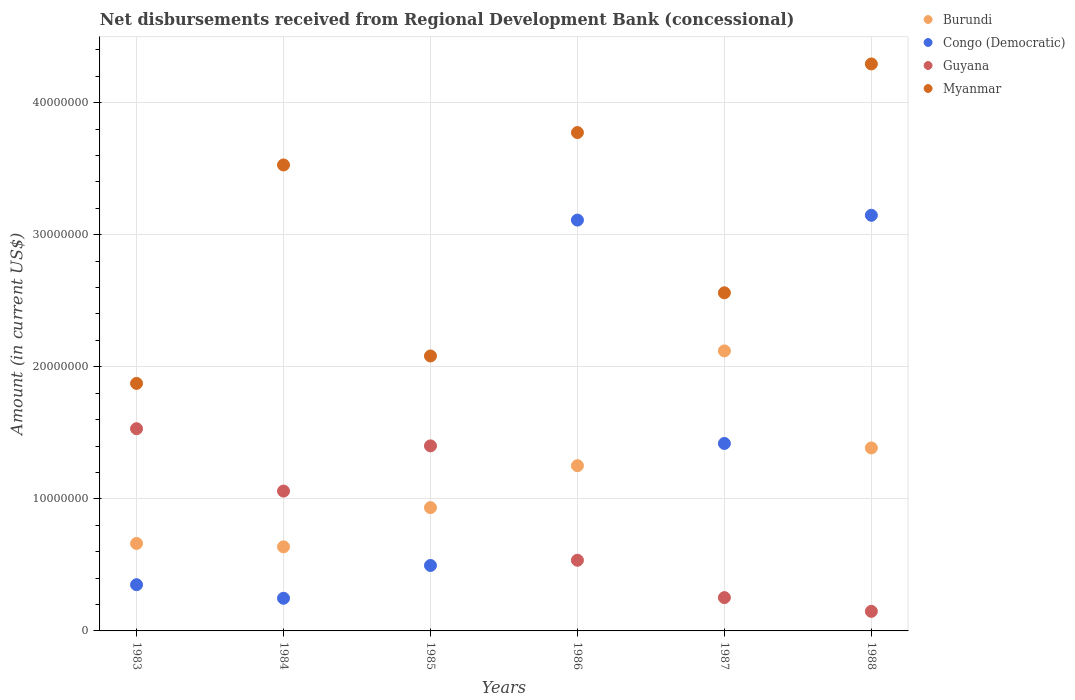How many different coloured dotlines are there?
Your response must be concise. 4. Is the number of dotlines equal to the number of legend labels?
Your response must be concise. Yes. What is the amount of disbursements received from Regional Development Bank in Guyana in 1984?
Your answer should be compact. 1.06e+07. Across all years, what is the maximum amount of disbursements received from Regional Development Bank in Myanmar?
Your answer should be very brief. 4.29e+07. Across all years, what is the minimum amount of disbursements received from Regional Development Bank in Congo (Democratic)?
Ensure brevity in your answer.  2.47e+06. In which year was the amount of disbursements received from Regional Development Bank in Burundi maximum?
Make the answer very short. 1987. In which year was the amount of disbursements received from Regional Development Bank in Burundi minimum?
Make the answer very short. 1984. What is the total amount of disbursements received from Regional Development Bank in Myanmar in the graph?
Your response must be concise. 1.81e+08. What is the difference between the amount of disbursements received from Regional Development Bank in Myanmar in 1983 and that in 1984?
Your answer should be compact. -1.65e+07. What is the difference between the amount of disbursements received from Regional Development Bank in Myanmar in 1983 and the amount of disbursements received from Regional Development Bank in Guyana in 1986?
Provide a short and direct response. 1.34e+07. What is the average amount of disbursements received from Regional Development Bank in Myanmar per year?
Your response must be concise. 3.02e+07. In the year 1987, what is the difference between the amount of disbursements received from Regional Development Bank in Guyana and amount of disbursements received from Regional Development Bank in Congo (Democratic)?
Offer a terse response. -1.17e+07. What is the ratio of the amount of disbursements received from Regional Development Bank in Congo (Democratic) in 1987 to that in 1988?
Your response must be concise. 0.45. Is the amount of disbursements received from Regional Development Bank in Burundi in 1986 less than that in 1987?
Your response must be concise. Yes. What is the difference between the highest and the second highest amount of disbursements received from Regional Development Bank in Guyana?
Offer a very short reply. 1.30e+06. What is the difference between the highest and the lowest amount of disbursements received from Regional Development Bank in Myanmar?
Make the answer very short. 2.42e+07. Is it the case that in every year, the sum of the amount of disbursements received from Regional Development Bank in Congo (Democratic) and amount of disbursements received from Regional Development Bank in Burundi  is greater than the amount of disbursements received from Regional Development Bank in Myanmar?
Your answer should be very brief. No. Does the amount of disbursements received from Regional Development Bank in Myanmar monotonically increase over the years?
Keep it short and to the point. No. Is the amount of disbursements received from Regional Development Bank in Burundi strictly less than the amount of disbursements received from Regional Development Bank in Myanmar over the years?
Your answer should be very brief. Yes. How many years are there in the graph?
Offer a very short reply. 6. Are the values on the major ticks of Y-axis written in scientific E-notation?
Your response must be concise. No. Does the graph contain any zero values?
Offer a very short reply. No. Where does the legend appear in the graph?
Your answer should be very brief. Top right. How many legend labels are there?
Your response must be concise. 4. What is the title of the graph?
Offer a terse response. Net disbursements received from Regional Development Bank (concessional). What is the label or title of the X-axis?
Offer a terse response. Years. What is the Amount (in current US$) in Burundi in 1983?
Offer a very short reply. 6.62e+06. What is the Amount (in current US$) in Congo (Democratic) in 1983?
Keep it short and to the point. 3.50e+06. What is the Amount (in current US$) of Guyana in 1983?
Give a very brief answer. 1.53e+07. What is the Amount (in current US$) in Myanmar in 1983?
Provide a short and direct response. 1.87e+07. What is the Amount (in current US$) of Burundi in 1984?
Your response must be concise. 6.37e+06. What is the Amount (in current US$) in Congo (Democratic) in 1984?
Provide a short and direct response. 2.47e+06. What is the Amount (in current US$) of Guyana in 1984?
Your answer should be very brief. 1.06e+07. What is the Amount (in current US$) in Myanmar in 1984?
Your response must be concise. 3.53e+07. What is the Amount (in current US$) of Burundi in 1985?
Keep it short and to the point. 9.34e+06. What is the Amount (in current US$) in Congo (Democratic) in 1985?
Your answer should be very brief. 4.96e+06. What is the Amount (in current US$) of Guyana in 1985?
Provide a succinct answer. 1.40e+07. What is the Amount (in current US$) in Myanmar in 1985?
Your answer should be very brief. 2.08e+07. What is the Amount (in current US$) in Burundi in 1986?
Your answer should be compact. 1.25e+07. What is the Amount (in current US$) of Congo (Democratic) in 1986?
Give a very brief answer. 3.11e+07. What is the Amount (in current US$) in Guyana in 1986?
Give a very brief answer. 5.35e+06. What is the Amount (in current US$) of Myanmar in 1986?
Offer a terse response. 3.77e+07. What is the Amount (in current US$) of Burundi in 1987?
Provide a succinct answer. 2.12e+07. What is the Amount (in current US$) in Congo (Democratic) in 1987?
Make the answer very short. 1.42e+07. What is the Amount (in current US$) in Guyana in 1987?
Your response must be concise. 2.52e+06. What is the Amount (in current US$) of Myanmar in 1987?
Ensure brevity in your answer.  2.56e+07. What is the Amount (in current US$) of Burundi in 1988?
Give a very brief answer. 1.39e+07. What is the Amount (in current US$) of Congo (Democratic) in 1988?
Provide a succinct answer. 3.15e+07. What is the Amount (in current US$) in Guyana in 1988?
Make the answer very short. 1.48e+06. What is the Amount (in current US$) in Myanmar in 1988?
Keep it short and to the point. 4.29e+07. Across all years, what is the maximum Amount (in current US$) in Burundi?
Keep it short and to the point. 2.12e+07. Across all years, what is the maximum Amount (in current US$) in Congo (Democratic)?
Make the answer very short. 3.15e+07. Across all years, what is the maximum Amount (in current US$) of Guyana?
Offer a very short reply. 1.53e+07. Across all years, what is the maximum Amount (in current US$) in Myanmar?
Provide a short and direct response. 4.29e+07. Across all years, what is the minimum Amount (in current US$) of Burundi?
Keep it short and to the point. 6.37e+06. Across all years, what is the minimum Amount (in current US$) in Congo (Democratic)?
Keep it short and to the point. 2.47e+06. Across all years, what is the minimum Amount (in current US$) of Guyana?
Ensure brevity in your answer.  1.48e+06. Across all years, what is the minimum Amount (in current US$) in Myanmar?
Your response must be concise. 1.87e+07. What is the total Amount (in current US$) of Burundi in the graph?
Provide a short and direct response. 6.99e+07. What is the total Amount (in current US$) of Congo (Democratic) in the graph?
Your response must be concise. 8.77e+07. What is the total Amount (in current US$) of Guyana in the graph?
Make the answer very short. 4.93e+07. What is the total Amount (in current US$) of Myanmar in the graph?
Your response must be concise. 1.81e+08. What is the difference between the Amount (in current US$) of Burundi in 1983 and that in 1984?
Give a very brief answer. 2.53e+05. What is the difference between the Amount (in current US$) of Congo (Democratic) in 1983 and that in 1984?
Your response must be concise. 1.03e+06. What is the difference between the Amount (in current US$) of Guyana in 1983 and that in 1984?
Offer a terse response. 4.72e+06. What is the difference between the Amount (in current US$) of Myanmar in 1983 and that in 1984?
Ensure brevity in your answer.  -1.65e+07. What is the difference between the Amount (in current US$) of Burundi in 1983 and that in 1985?
Your answer should be compact. -2.72e+06. What is the difference between the Amount (in current US$) in Congo (Democratic) in 1983 and that in 1985?
Your answer should be very brief. -1.46e+06. What is the difference between the Amount (in current US$) in Guyana in 1983 and that in 1985?
Give a very brief answer. 1.30e+06. What is the difference between the Amount (in current US$) in Myanmar in 1983 and that in 1985?
Keep it short and to the point. -2.08e+06. What is the difference between the Amount (in current US$) in Burundi in 1983 and that in 1986?
Offer a very short reply. -5.89e+06. What is the difference between the Amount (in current US$) in Congo (Democratic) in 1983 and that in 1986?
Your answer should be compact. -2.76e+07. What is the difference between the Amount (in current US$) in Guyana in 1983 and that in 1986?
Your answer should be compact. 9.96e+06. What is the difference between the Amount (in current US$) of Myanmar in 1983 and that in 1986?
Provide a short and direct response. -1.90e+07. What is the difference between the Amount (in current US$) in Burundi in 1983 and that in 1987?
Keep it short and to the point. -1.46e+07. What is the difference between the Amount (in current US$) of Congo (Democratic) in 1983 and that in 1987?
Make the answer very short. -1.07e+07. What is the difference between the Amount (in current US$) in Guyana in 1983 and that in 1987?
Ensure brevity in your answer.  1.28e+07. What is the difference between the Amount (in current US$) in Myanmar in 1983 and that in 1987?
Keep it short and to the point. -6.86e+06. What is the difference between the Amount (in current US$) of Burundi in 1983 and that in 1988?
Ensure brevity in your answer.  -7.23e+06. What is the difference between the Amount (in current US$) in Congo (Democratic) in 1983 and that in 1988?
Keep it short and to the point. -2.80e+07. What is the difference between the Amount (in current US$) of Guyana in 1983 and that in 1988?
Offer a very short reply. 1.38e+07. What is the difference between the Amount (in current US$) in Myanmar in 1983 and that in 1988?
Offer a terse response. -2.42e+07. What is the difference between the Amount (in current US$) of Burundi in 1984 and that in 1985?
Your response must be concise. -2.97e+06. What is the difference between the Amount (in current US$) in Congo (Democratic) in 1984 and that in 1985?
Provide a short and direct response. -2.48e+06. What is the difference between the Amount (in current US$) of Guyana in 1984 and that in 1985?
Provide a short and direct response. -3.42e+06. What is the difference between the Amount (in current US$) in Myanmar in 1984 and that in 1985?
Your answer should be compact. 1.45e+07. What is the difference between the Amount (in current US$) of Burundi in 1984 and that in 1986?
Offer a very short reply. -6.14e+06. What is the difference between the Amount (in current US$) of Congo (Democratic) in 1984 and that in 1986?
Provide a succinct answer. -2.86e+07. What is the difference between the Amount (in current US$) in Guyana in 1984 and that in 1986?
Your answer should be very brief. 5.24e+06. What is the difference between the Amount (in current US$) in Myanmar in 1984 and that in 1986?
Provide a succinct answer. -2.45e+06. What is the difference between the Amount (in current US$) in Burundi in 1984 and that in 1987?
Provide a short and direct response. -1.48e+07. What is the difference between the Amount (in current US$) of Congo (Democratic) in 1984 and that in 1987?
Your answer should be compact. -1.17e+07. What is the difference between the Amount (in current US$) of Guyana in 1984 and that in 1987?
Make the answer very short. 8.07e+06. What is the difference between the Amount (in current US$) of Myanmar in 1984 and that in 1987?
Your answer should be compact. 9.68e+06. What is the difference between the Amount (in current US$) of Burundi in 1984 and that in 1988?
Make the answer very short. -7.49e+06. What is the difference between the Amount (in current US$) in Congo (Democratic) in 1984 and that in 1988?
Your answer should be compact. -2.90e+07. What is the difference between the Amount (in current US$) of Guyana in 1984 and that in 1988?
Your answer should be very brief. 9.11e+06. What is the difference between the Amount (in current US$) of Myanmar in 1984 and that in 1988?
Offer a terse response. -7.65e+06. What is the difference between the Amount (in current US$) in Burundi in 1985 and that in 1986?
Offer a very short reply. -3.18e+06. What is the difference between the Amount (in current US$) in Congo (Democratic) in 1985 and that in 1986?
Give a very brief answer. -2.62e+07. What is the difference between the Amount (in current US$) in Guyana in 1985 and that in 1986?
Keep it short and to the point. 8.66e+06. What is the difference between the Amount (in current US$) in Myanmar in 1985 and that in 1986?
Ensure brevity in your answer.  -1.69e+07. What is the difference between the Amount (in current US$) of Burundi in 1985 and that in 1987?
Make the answer very short. -1.19e+07. What is the difference between the Amount (in current US$) in Congo (Democratic) in 1985 and that in 1987?
Offer a very short reply. -9.24e+06. What is the difference between the Amount (in current US$) in Guyana in 1985 and that in 1987?
Your answer should be compact. 1.15e+07. What is the difference between the Amount (in current US$) of Myanmar in 1985 and that in 1987?
Provide a short and direct response. -4.78e+06. What is the difference between the Amount (in current US$) of Burundi in 1985 and that in 1988?
Your response must be concise. -4.52e+06. What is the difference between the Amount (in current US$) in Congo (Democratic) in 1985 and that in 1988?
Ensure brevity in your answer.  -2.65e+07. What is the difference between the Amount (in current US$) in Guyana in 1985 and that in 1988?
Give a very brief answer. 1.25e+07. What is the difference between the Amount (in current US$) of Myanmar in 1985 and that in 1988?
Your response must be concise. -2.21e+07. What is the difference between the Amount (in current US$) in Burundi in 1986 and that in 1987?
Make the answer very short. -8.69e+06. What is the difference between the Amount (in current US$) of Congo (Democratic) in 1986 and that in 1987?
Offer a terse response. 1.69e+07. What is the difference between the Amount (in current US$) in Guyana in 1986 and that in 1987?
Your response must be concise. 2.83e+06. What is the difference between the Amount (in current US$) in Myanmar in 1986 and that in 1987?
Your answer should be compact. 1.21e+07. What is the difference between the Amount (in current US$) in Burundi in 1986 and that in 1988?
Provide a succinct answer. -1.34e+06. What is the difference between the Amount (in current US$) of Congo (Democratic) in 1986 and that in 1988?
Your answer should be very brief. -3.65e+05. What is the difference between the Amount (in current US$) of Guyana in 1986 and that in 1988?
Your answer should be very brief. 3.87e+06. What is the difference between the Amount (in current US$) of Myanmar in 1986 and that in 1988?
Provide a succinct answer. -5.20e+06. What is the difference between the Amount (in current US$) in Burundi in 1987 and that in 1988?
Give a very brief answer. 7.35e+06. What is the difference between the Amount (in current US$) of Congo (Democratic) in 1987 and that in 1988?
Your response must be concise. -1.73e+07. What is the difference between the Amount (in current US$) in Guyana in 1987 and that in 1988?
Offer a terse response. 1.04e+06. What is the difference between the Amount (in current US$) in Myanmar in 1987 and that in 1988?
Make the answer very short. -1.73e+07. What is the difference between the Amount (in current US$) of Burundi in 1983 and the Amount (in current US$) of Congo (Democratic) in 1984?
Make the answer very short. 4.15e+06. What is the difference between the Amount (in current US$) in Burundi in 1983 and the Amount (in current US$) in Guyana in 1984?
Your answer should be compact. -3.97e+06. What is the difference between the Amount (in current US$) of Burundi in 1983 and the Amount (in current US$) of Myanmar in 1984?
Keep it short and to the point. -2.87e+07. What is the difference between the Amount (in current US$) of Congo (Democratic) in 1983 and the Amount (in current US$) of Guyana in 1984?
Offer a very short reply. -7.09e+06. What is the difference between the Amount (in current US$) of Congo (Democratic) in 1983 and the Amount (in current US$) of Myanmar in 1984?
Provide a short and direct response. -3.18e+07. What is the difference between the Amount (in current US$) of Guyana in 1983 and the Amount (in current US$) of Myanmar in 1984?
Provide a short and direct response. -2.00e+07. What is the difference between the Amount (in current US$) in Burundi in 1983 and the Amount (in current US$) in Congo (Democratic) in 1985?
Ensure brevity in your answer.  1.66e+06. What is the difference between the Amount (in current US$) of Burundi in 1983 and the Amount (in current US$) of Guyana in 1985?
Ensure brevity in your answer.  -7.39e+06. What is the difference between the Amount (in current US$) in Burundi in 1983 and the Amount (in current US$) in Myanmar in 1985?
Your answer should be very brief. -1.42e+07. What is the difference between the Amount (in current US$) in Congo (Democratic) in 1983 and the Amount (in current US$) in Guyana in 1985?
Provide a short and direct response. -1.05e+07. What is the difference between the Amount (in current US$) in Congo (Democratic) in 1983 and the Amount (in current US$) in Myanmar in 1985?
Make the answer very short. -1.73e+07. What is the difference between the Amount (in current US$) of Guyana in 1983 and the Amount (in current US$) of Myanmar in 1985?
Give a very brief answer. -5.51e+06. What is the difference between the Amount (in current US$) of Burundi in 1983 and the Amount (in current US$) of Congo (Democratic) in 1986?
Make the answer very short. -2.45e+07. What is the difference between the Amount (in current US$) in Burundi in 1983 and the Amount (in current US$) in Guyana in 1986?
Provide a succinct answer. 1.27e+06. What is the difference between the Amount (in current US$) in Burundi in 1983 and the Amount (in current US$) in Myanmar in 1986?
Give a very brief answer. -3.11e+07. What is the difference between the Amount (in current US$) of Congo (Democratic) in 1983 and the Amount (in current US$) of Guyana in 1986?
Keep it short and to the point. -1.85e+06. What is the difference between the Amount (in current US$) of Congo (Democratic) in 1983 and the Amount (in current US$) of Myanmar in 1986?
Offer a terse response. -3.42e+07. What is the difference between the Amount (in current US$) of Guyana in 1983 and the Amount (in current US$) of Myanmar in 1986?
Your answer should be compact. -2.24e+07. What is the difference between the Amount (in current US$) in Burundi in 1983 and the Amount (in current US$) in Congo (Democratic) in 1987?
Offer a terse response. -7.57e+06. What is the difference between the Amount (in current US$) in Burundi in 1983 and the Amount (in current US$) in Guyana in 1987?
Offer a very short reply. 4.10e+06. What is the difference between the Amount (in current US$) in Burundi in 1983 and the Amount (in current US$) in Myanmar in 1987?
Offer a very short reply. -1.90e+07. What is the difference between the Amount (in current US$) in Congo (Democratic) in 1983 and the Amount (in current US$) in Guyana in 1987?
Ensure brevity in your answer.  9.77e+05. What is the difference between the Amount (in current US$) of Congo (Democratic) in 1983 and the Amount (in current US$) of Myanmar in 1987?
Give a very brief answer. -2.21e+07. What is the difference between the Amount (in current US$) of Guyana in 1983 and the Amount (in current US$) of Myanmar in 1987?
Ensure brevity in your answer.  -1.03e+07. What is the difference between the Amount (in current US$) of Burundi in 1983 and the Amount (in current US$) of Congo (Democratic) in 1988?
Offer a terse response. -2.49e+07. What is the difference between the Amount (in current US$) in Burundi in 1983 and the Amount (in current US$) in Guyana in 1988?
Your answer should be compact. 5.14e+06. What is the difference between the Amount (in current US$) of Burundi in 1983 and the Amount (in current US$) of Myanmar in 1988?
Provide a short and direct response. -3.63e+07. What is the difference between the Amount (in current US$) in Congo (Democratic) in 1983 and the Amount (in current US$) in Guyana in 1988?
Provide a succinct answer. 2.02e+06. What is the difference between the Amount (in current US$) in Congo (Democratic) in 1983 and the Amount (in current US$) in Myanmar in 1988?
Your answer should be very brief. -3.94e+07. What is the difference between the Amount (in current US$) in Guyana in 1983 and the Amount (in current US$) in Myanmar in 1988?
Offer a terse response. -2.76e+07. What is the difference between the Amount (in current US$) of Burundi in 1984 and the Amount (in current US$) of Congo (Democratic) in 1985?
Give a very brief answer. 1.41e+06. What is the difference between the Amount (in current US$) of Burundi in 1984 and the Amount (in current US$) of Guyana in 1985?
Your answer should be very brief. -7.64e+06. What is the difference between the Amount (in current US$) in Burundi in 1984 and the Amount (in current US$) in Myanmar in 1985?
Provide a short and direct response. -1.45e+07. What is the difference between the Amount (in current US$) in Congo (Democratic) in 1984 and the Amount (in current US$) in Guyana in 1985?
Keep it short and to the point. -1.15e+07. What is the difference between the Amount (in current US$) in Congo (Democratic) in 1984 and the Amount (in current US$) in Myanmar in 1985?
Your answer should be very brief. -1.83e+07. What is the difference between the Amount (in current US$) of Guyana in 1984 and the Amount (in current US$) of Myanmar in 1985?
Your answer should be compact. -1.02e+07. What is the difference between the Amount (in current US$) in Burundi in 1984 and the Amount (in current US$) in Congo (Democratic) in 1986?
Offer a very short reply. -2.47e+07. What is the difference between the Amount (in current US$) of Burundi in 1984 and the Amount (in current US$) of Guyana in 1986?
Offer a very short reply. 1.02e+06. What is the difference between the Amount (in current US$) in Burundi in 1984 and the Amount (in current US$) in Myanmar in 1986?
Offer a very short reply. -3.14e+07. What is the difference between the Amount (in current US$) in Congo (Democratic) in 1984 and the Amount (in current US$) in Guyana in 1986?
Provide a short and direct response. -2.88e+06. What is the difference between the Amount (in current US$) of Congo (Democratic) in 1984 and the Amount (in current US$) of Myanmar in 1986?
Your answer should be very brief. -3.53e+07. What is the difference between the Amount (in current US$) in Guyana in 1984 and the Amount (in current US$) in Myanmar in 1986?
Give a very brief answer. -2.71e+07. What is the difference between the Amount (in current US$) of Burundi in 1984 and the Amount (in current US$) of Congo (Democratic) in 1987?
Your answer should be compact. -7.83e+06. What is the difference between the Amount (in current US$) of Burundi in 1984 and the Amount (in current US$) of Guyana in 1987?
Offer a very short reply. 3.85e+06. What is the difference between the Amount (in current US$) of Burundi in 1984 and the Amount (in current US$) of Myanmar in 1987?
Ensure brevity in your answer.  -1.92e+07. What is the difference between the Amount (in current US$) of Congo (Democratic) in 1984 and the Amount (in current US$) of Guyana in 1987?
Offer a very short reply. -4.90e+04. What is the difference between the Amount (in current US$) in Congo (Democratic) in 1984 and the Amount (in current US$) in Myanmar in 1987?
Your answer should be very brief. -2.31e+07. What is the difference between the Amount (in current US$) in Guyana in 1984 and the Amount (in current US$) in Myanmar in 1987?
Your answer should be very brief. -1.50e+07. What is the difference between the Amount (in current US$) of Burundi in 1984 and the Amount (in current US$) of Congo (Democratic) in 1988?
Provide a short and direct response. -2.51e+07. What is the difference between the Amount (in current US$) in Burundi in 1984 and the Amount (in current US$) in Guyana in 1988?
Give a very brief answer. 4.89e+06. What is the difference between the Amount (in current US$) in Burundi in 1984 and the Amount (in current US$) in Myanmar in 1988?
Your response must be concise. -3.66e+07. What is the difference between the Amount (in current US$) of Congo (Democratic) in 1984 and the Amount (in current US$) of Guyana in 1988?
Make the answer very short. 9.91e+05. What is the difference between the Amount (in current US$) of Congo (Democratic) in 1984 and the Amount (in current US$) of Myanmar in 1988?
Provide a succinct answer. -4.05e+07. What is the difference between the Amount (in current US$) in Guyana in 1984 and the Amount (in current US$) in Myanmar in 1988?
Your answer should be very brief. -3.23e+07. What is the difference between the Amount (in current US$) of Burundi in 1985 and the Amount (in current US$) of Congo (Democratic) in 1986?
Offer a very short reply. -2.18e+07. What is the difference between the Amount (in current US$) in Burundi in 1985 and the Amount (in current US$) in Guyana in 1986?
Your response must be concise. 3.98e+06. What is the difference between the Amount (in current US$) in Burundi in 1985 and the Amount (in current US$) in Myanmar in 1986?
Offer a very short reply. -2.84e+07. What is the difference between the Amount (in current US$) of Congo (Democratic) in 1985 and the Amount (in current US$) of Guyana in 1986?
Provide a short and direct response. -3.95e+05. What is the difference between the Amount (in current US$) in Congo (Democratic) in 1985 and the Amount (in current US$) in Myanmar in 1986?
Offer a very short reply. -3.28e+07. What is the difference between the Amount (in current US$) of Guyana in 1985 and the Amount (in current US$) of Myanmar in 1986?
Your answer should be compact. -2.37e+07. What is the difference between the Amount (in current US$) of Burundi in 1985 and the Amount (in current US$) of Congo (Democratic) in 1987?
Ensure brevity in your answer.  -4.86e+06. What is the difference between the Amount (in current US$) in Burundi in 1985 and the Amount (in current US$) in Guyana in 1987?
Make the answer very short. 6.81e+06. What is the difference between the Amount (in current US$) in Burundi in 1985 and the Amount (in current US$) in Myanmar in 1987?
Provide a succinct answer. -1.63e+07. What is the difference between the Amount (in current US$) of Congo (Democratic) in 1985 and the Amount (in current US$) of Guyana in 1987?
Offer a terse response. 2.43e+06. What is the difference between the Amount (in current US$) of Congo (Democratic) in 1985 and the Amount (in current US$) of Myanmar in 1987?
Keep it short and to the point. -2.06e+07. What is the difference between the Amount (in current US$) of Guyana in 1985 and the Amount (in current US$) of Myanmar in 1987?
Your answer should be compact. -1.16e+07. What is the difference between the Amount (in current US$) of Burundi in 1985 and the Amount (in current US$) of Congo (Democratic) in 1988?
Provide a succinct answer. -2.21e+07. What is the difference between the Amount (in current US$) of Burundi in 1985 and the Amount (in current US$) of Guyana in 1988?
Give a very brief answer. 7.85e+06. What is the difference between the Amount (in current US$) of Burundi in 1985 and the Amount (in current US$) of Myanmar in 1988?
Give a very brief answer. -3.36e+07. What is the difference between the Amount (in current US$) in Congo (Democratic) in 1985 and the Amount (in current US$) in Guyana in 1988?
Your answer should be very brief. 3.47e+06. What is the difference between the Amount (in current US$) of Congo (Democratic) in 1985 and the Amount (in current US$) of Myanmar in 1988?
Offer a terse response. -3.80e+07. What is the difference between the Amount (in current US$) in Guyana in 1985 and the Amount (in current US$) in Myanmar in 1988?
Keep it short and to the point. -2.89e+07. What is the difference between the Amount (in current US$) in Burundi in 1986 and the Amount (in current US$) in Congo (Democratic) in 1987?
Keep it short and to the point. -1.68e+06. What is the difference between the Amount (in current US$) in Burundi in 1986 and the Amount (in current US$) in Guyana in 1987?
Make the answer very short. 9.99e+06. What is the difference between the Amount (in current US$) of Burundi in 1986 and the Amount (in current US$) of Myanmar in 1987?
Ensure brevity in your answer.  -1.31e+07. What is the difference between the Amount (in current US$) of Congo (Democratic) in 1986 and the Amount (in current US$) of Guyana in 1987?
Offer a very short reply. 2.86e+07. What is the difference between the Amount (in current US$) of Congo (Democratic) in 1986 and the Amount (in current US$) of Myanmar in 1987?
Give a very brief answer. 5.51e+06. What is the difference between the Amount (in current US$) of Guyana in 1986 and the Amount (in current US$) of Myanmar in 1987?
Provide a short and direct response. -2.02e+07. What is the difference between the Amount (in current US$) in Burundi in 1986 and the Amount (in current US$) in Congo (Democratic) in 1988?
Give a very brief answer. -1.90e+07. What is the difference between the Amount (in current US$) in Burundi in 1986 and the Amount (in current US$) in Guyana in 1988?
Give a very brief answer. 1.10e+07. What is the difference between the Amount (in current US$) in Burundi in 1986 and the Amount (in current US$) in Myanmar in 1988?
Offer a very short reply. -3.04e+07. What is the difference between the Amount (in current US$) of Congo (Democratic) in 1986 and the Amount (in current US$) of Guyana in 1988?
Give a very brief answer. 2.96e+07. What is the difference between the Amount (in current US$) of Congo (Democratic) in 1986 and the Amount (in current US$) of Myanmar in 1988?
Offer a very short reply. -1.18e+07. What is the difference between the Amount (in current US$) in Guyana in 1986 and the Amount (in current US$) in Myanmar in 1988?
Make the answer very short. -3.76e+07. What is the difference between the Amount (in current US$) in Burundi in 1987 and the Amount (in current US$) in Congo (Democratic) in 1988?
Offer a terse response. -1.03e+07. What is the difference between the Amount (in current US$) in Burundi in 1987 and the Amount (in current US$) in Guyana in 1988?
Give a very brief answer. 1.97e+07. What is the difference between the Amount (in current US$) of Burundi in 1987 and the Amount (in current US$) of Myanmar in 1988?
Keep it short and to the point. -2.17e+07. What is the difference between the Amount (in current US$) in Congo (Democratic) in 1987 and the Amount (in current US$) in Guyana in 1988?
Make the answer very short. 1.27e+07. What is the difference between the Amount (in current US$) in Congo (Democratic) in 1987 and the Amount (in current US$) in Myanmar in 1988?
Give a very brief answer. -2.87e+07. What is the difference between the Amount (in current US$) in Guyana in 1987 and the Amount (in current US$) in Myanmar in 1988?
Provide a succinct answer. -4.04e+07. What is the average Amount (in current US$) of Burundi per year?
Provide a short and direct response. 1.16e+07. What is the average Amount (in current US$) of Congo (Democratic) per year?
Ensure brevity in your answer.  1.46e+07. What is the average Amount (in current US$) in Guyana per year?
Offer a very short reply. 8.21e+06. What is the average Amount (in current US$) in Myanmar per year?
Give a very brief answer. 3.02e+07. In the year 1983, what is the difference between the Amount (in current US$) in Burundi and Amount (in current US$) in Congo (Democratic)?
Your answer should be very brief. 3.12e+06. In the year 1983, what is the difference between the Amount (in current US$) of Burundi and Amount (in current US$) of Guyana?
Provide a succinct answer. -8.69e+06. In the year 1983, what is the difference between the Amount (in current US$) in Burundi and Amount (in current US$) in Myanmar?
Offer a terse response. -1.21e+07. In the year 1983, what is the difference between the Amount (in current US$) in Congo (Democratic) and Amount (in current US$) in Guyana?
Provide a succinct answer. -1.18e+07. In the year 1983, what is the difference between the Amount (in current US$) in Congo (Democratic) and Amount (in current US$) in Myanmar?
Ensure brevity in your answer.  -1.52e+07. In the year 1983, what is the difference between the Amount (in current US$) in Guyana and Amount (in current US$) in Myanmar?
Provide a succinct answer. -3.43e+06. In the year 1984, what is the difference between the Amount (in current US$) in Burundi and Amount (in current US$) in Congo (Democratic)?
Provide a succinct answer. 3.90e+06. In the year 1984, what is the difference between the Amount (in current US$) in Burundi and Amount (in current US$) in Guyana?
Make the answer very short. -4.22e+06. In the year 1984, what is the difference between the Amount (in current US$) in Burundi and Amount (in current US$) in Myanmar?
Ensure brevity in your answer.  -2.89e+07. In the year 1984, what is the difference between the Amount (in current US$) of Congo (Democratic) and Amount (in current US$) of Guyana?
Keep it short and to the point. -8.12e+06. In the year 1984, what is the difference between the Amount (in current US$) of Congo (Democratic) and Amount (in current US$) of Myanmar?
Ensure brevity in your answer.  -3.28e+07. In the year 1984, what is the difference between the Amount (in current US$) in Guyana and Amount (in current US$) in Myanmar?
Your response must be concise. -2.47e+07. In the year 1985, what is the difference between the Amount (in current US$) in Burundi and Amount (in current US$) in Congo (Democratic)?
Offer a terse response. 4.38e+06. In the year 1985, what is the difference between the Amount (in current US$) of Burundi and Amount (in current US$) of Guyana?
Provide a short and direct response. -4.68e+06. In the year 1985, what is the difference between the Amount (in current US$) of Burundi and Amount (in current US$) of Myanmar?
Give a very brief answer. -1.15e+07. In the year 1985, what is the difference between the Amount (in current US$) in Congo (Democratic) and Amount (in current US$) in Guyana?
Ensure brevity in your answer.  -9.06e+06. In the year 1985, what is the difference between the Amount (in current US$) in Congo (Democratic) and Amount (in current US$) in Myanmar?
Offer a very short reply. -1.59e+07. In the year 1985, what is the difference between the Amount (in current US$) of Guyana and Amount (in current US$) of Myanmar?
Give a very brief answer. -6.81e+06. In the year 1986, what is the difference between the Amount (in current US$) of Burundi and Amount (in current US$) of Congo (Democratic)?
Your response must be concise. -1.86e+07. In the year 1986, what is the difference between the Amount (in current US$) in Burundi and Amount (in current US$) in Guyana?
Your answer should be very brief. 7.16e+06. In the year 1986, what is the difference between the Amount (in current US$) in Burundi and Amount (in current US$) in Myanmar?
Your answer should be compact. -2.52e+07. In the year 1986, what is the difference between the Amount (in current US$) in Congo (Democratic) and Amount (in current US$) in Guyana?
Offer a terse response. 2.58e+07. In the year 1986, what is the difference between the Amount (in current US$) of Congo (Democratic) and Amount (in current US$) of Myanmar?
Provide a short and direct response. -6.63e+06. In the year 1986, what is the difference between the Amount (in current US$) in Guyana and Amount (in current US$) in Myanmar?
Your response must be concise. -3.24e+07. In the year 1987, what is the difference between the Amount (in current US$) of Burundi and Amount (in current US$) of Congo (Democratic)?
Give a very brief answer. 7.01e+06. In the year 1987, what is the difference between the Amount (in current US$) of Burundi and Amount (in current US$) of Guyana?
Your response must be concise. 1.87e+07. In the year 1987, what is the difference between the Amount (in current US$) in Burundi and Amount (in current US$) in Myanmar?
Give a very brief answer. -4.40e+06. In the year 1987, what is the difference between the Amount (in current US$) of Congo (Democratic) and Amount (in current US$) of Guyana?
Offer a terse response. 1.17e+07. In the year 1987, what is the difference between the Amount (in current US$) in Congo (Democratic) and Amount (in current US$) in Myanmar?
Keep it short and to the point. -1.14e+07. In the year 1987, what is the difference between the Amount (in current US$) of Guyana and Amount (in current US$) of Myanmar?
Keep it short and to the point. -2.31e+07. In the year 1988, what is the difference between the Amount (in current US$) in Burundi and Amount (in current US$) in Congo (Democratic)?
Your response must be concise. -1.76e+07. In the year 1988, what is the difference between the Amount (in current US$) in Burundi and Amount (in current US$) in Guyana?
Give a very brief answer. 1.24e+07. In the year 1988, what is the difference between the Amount (in current US$) in Burundi and Amount (in current US$) in Myanmar?
Make the answer very short. -2.91e+07. In the year 1988, what is the difference between the Amount (in current US$) in Congo (Democratic) and Amount (in current US$) in Guyana?
Give a very brief answer. 3.00e+07. In the year 1988, what is the difference between the Amount (in current US$) in Congo (Democratic) and Amount (in current US$) in Myanmar?
Keep it short and to the point. -1.15e+07. In the year 1988, what is the difference between the Amount (in current US$) in Guyana and Amount (in current US$) in Myanmar?
Your answer should be very brief. -4.14e+07. What is the ratio of the Amount (in current US$) in Burundi in 1983 to that in 1984?
Offer a very short reply. 1.04. What is the ratio of the Amount (in current US$) in Congo (Democratic) in 1983 to that in 1984?
Provide a succinct answer. 1.41. What is the ratio of the Amount (in current US$) in Guyana in 1983 to that in 1984?
Your answer should be compact. 1.45. What is the ratio of the Amount (in current US$) in Myanmar in 1983 to that in 1984?
Provide a succinct answer. 0.53. What is the ratio of the Amount (in current US$) in Burundi in 1983 to that in 1985?
Your answer should be compact. 0.71. What is the ratio of the Amount (in current US$) in Congo (Democratic) in 1983 to that in 1985?
Your answer should be compact. 0.71. What is the ratio of the Amount (in current US$) in Guyana in 1983 to that in 1985?
Give a very brief answer. 1.09. What is the ratio of the Amount (in current US$) of Myanmar in 1983 to that in 1985?
Provide a succinct answer. 0.9. What is the ratio of the Amount (in current US$) of Burundi in 1983 to that in 1986?
Your answer should be compact. 0.53. What is the ratio of the Amount (in current US$) of Congo (Democratic) in 1983 to that in 1986?
Ensure brevity in your answer.  0.11. What is the ratio of the Amount (in current US$) of Guyana in 1983 to that in 1986?
Provide a short and direct response. 2.86. What is the ratio of the Amount (in current US$) in Myanmar in 1983 to that in 1986?
Provide a short and direct response. 0.5. What is the ratio of the Amount (in current US$) in Burundi in 1983 to that in 1987?
Offer a terse response. 0.31. What is the ratio of the Amount (in current US$) of Congo (Democratic) in 1983 to that in 1987?
Give a very brief answer. 0.25. What is the ratio of the Amount (in current US$) in Guyana in 1983 to that in 1987?
Offer a very short reply. 6.07. What is the ratio of the Amount (in current US$) in Myanmar in 1983 to that in 1987?
Provide a short and direct response. 0.73. What is the ratio of the Amount (in current US$) in Burundi in 1983 to that in 1988?
Ensure brevity in your answer.  0.48. What is the ratio of the Amount (in current US$) of Congo (Democratic) in 1983 to that in 1988?
Give a very brief answer. 0.11. What is the ratio of the Amount (in current US$) of Guyana in 1983 to that in 1988?
Provide a short and direct response. 10.33. What is the ratio of the Amount (in current US$) of Myanmar in 1983 to that in 1988?
Your response must be concise. 0.44. What is the ratio of the Amount (in current US$) in Burundi in 1984 to that in 1985?
Offer a terse response. 0.68. What is the ratio of the Amount (in current US$) of Congo (Democratic) in 1984 to that in 1985?
Give a very brief answer. 0.5. What is the ratio of the Amount (in current US$) of Guyana in 1984 to that in 1985?
Provide a short and direct response. 0.76. What is the ratio of the Amount (in current US$) in Myanmar in 1984 to that in 1985?
Your answer should be very brief. 1.69. What is the ratio of the Amount (in current US$) of Burundi in 1984 to that in 1986?
Your response must be concise. 0.51. What is the ratio of the Amount (in current US$) in Congo (Democratic) in 1984 to that in 1986?
Provide a short and direct response. 0.08. What is the ratio of the Amount (in current US$) of Guyana in 1984 to that in 1986?
Make the answer very short. 1.98. What is the ratio of the Amount (in current US$) in Myanmar in 1984 to that in 1986?
Ensure brevity in your answer.  0.94. What is the ratio of the Amount (in current US$) of Burundi in 1984 to that in 1987?
Provide a succinct answer. 0.3. What is the ratio of the Amount (in current US$) in Congo (Democratic) in 1984 to that in 1987?
Make the answer very short. 0.17. What is the ratio of the Amount (in current US$) in Guyana in 1984 to that in 1987?
Make the answer very short. 4.2. What is the ratio of the Amount (in current US$) in Myanmar in 1984 to that in 1987?
Provide a succinct answer. 1.38. What is the ratio of the Amount (in current US$) of Burundi in 1984 to that in 1988?
Offer a terse response. 0.46. What is the ratio of the Amount (in current US$) of Congo (Democratic) in 1984 to that in 1988?
Ensure brevity in your answer.  0.08. What is the ratio of the Amount (in current US$) of Guyana in 1984 to that in 1988?
Provide a short and direct response. 7.14. What is the ratio of the Amount (in current US$) of Myanmar in 1984 to that in 1988?
Ensure brevity in your answer.  0.82. What is the ratio of the Amount (in current US$) in Burundi in 1985 to that in 1986?
Keep it short and to the point. 0.75. What is the ratio of the Amount (in current US$) in Congo (Democratic) in 1985 to that in 1986?
Your response must be concise. 0.16. What is the ratio of the Amount (in current US$) in Guyana in 1985 to that in 1986?
Your answer should be compact. 2.62. What is the ratio of the Amount (in current US$) in Myanmar in 1985 to that in 1986?
Offer a very short reply. 0.55. What is the ratio of the Amount (in current US$) in Burundi in 1985 to that in 1987?
Provide a short and direct response. 0.44. What is the ratio of the Amount (in current US$) of Congo (Democratic) in 1985 to that in 1987?
Offer a terse response. 0.35. What is the ratio of the Amount (in current US$) of Guyana in 1985 to that in 1987?
Provide a succinct answer. 5.56. What is the ratio of the Amount (in current US$) of Myanmar in 1985 to that in 1987?
Provide a short and direct response. 0.81. What is the ratio of the Amount (in current US$) of Burundi in 1985 to that in 1988?
Provide a short and direct response. 0.67. What is the ratio of the Amount (in current US$) of Congo (Democratic) in 1985 to that in 1988?
Your answer should be very brief. 0.16. What is the ratio of the Amount (in current US$) in Guyana in 1985 to that in 1988?
Give a very brief answer. 9.45. What is the ratio of the Amount (in current US$) in Myanmar in 1985 to that in 1988?
Keep it short and to the point. 0.48. What is the ratio of the Amount (in current US$) of Burundi in 1986 to that in 1987?
Give a very brief answer. 0.59. What is the ratio of the Amount (in current US$) in Congo (Democratic) in 1986 to that in 1987?
Your answer should be very brief. 2.19. What is the ratio of the Amount (in current US$) of Guyana in 1986 to that in 1987?
Your response must be concise. 2.12. What is the ratio of the Amount (in current US$) in Myanmar in 1986 to that in 1987?
Provide a short and direct response. 1.47. What is the ratio of the Amount (in current US$) in Burundi in 1986 to that in 1988?
Your response must be concise. 0.9. What is the ratio of the Amount (in current US$) in Congo (Democratic) in 1986 to that in 1988?
Provide a succinct answer. 0.99. What is the ratio of the Amount (in current US$) in Guyana in 1986 to that in 1988?
Provide a succinct answer. 3.61. What is the ratio of the Amount (in current US$) of Myanmar in 1986 to that in 1988?
Your answer should be very brief. 0.88. What is the ratio of the Amount (in current US$) of Burundi in 1987 to that in 1988?
Your answer should be compact. 1.53. What is the ratio of the Amount (in current US$) of Congo (Democratic) in 1987 to that in 1988?
Your answer should be compact. 0.45. What is the ratio of the Amount (in current US$) of Guyana in 1987 to that in 1988?
Make the answer very short. 1.7. What is the ratio of the Amount (in current US$) of Myanmar in 1987 to that in 1988?
Provide a short and direct response. 0.6. What is the difference between the highest and the second highest Amount (in current US$) of Burundi?
Offer a terse response. 7.35e+06. What is the difference between the highest and the second highest Amount (in current US$) of Congo (Democratic)?
Offer a very short reply. 3.65e+05. What is the difference between the highest and the second highest Amount (in current US$) of Guyana?
Offer a terse response. 1.30e+06. What is the difference between the highest and the second highest Amount (in current US$) of Myanmar?
Your answer should be very brief. 5.20e+06. What is the difference between the highest and the lowest Amount (in current US$) in Burundi?
Make the answer very short. 1.48e+07. What is the difference between the highest and the lowest Amount (in current US$) in Congo (Democratic)?
Offer a very short reply. 2.90e+07. What is the difference between the highest and the lowest Amount (in current US$) of Guyana?
Your answer should be compact. 1.38e+07. What is the difference between the highest and the lowest Amount (in current US$) in Myanmar?
Keep it short and to the point. 2.42e+07. 